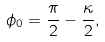Convert formula to latex. <formula><loc_0><loc_0><loc_500><loc_500>\phi _ { 0 } = \frac { \pi } { 2 } - \frac { \kappa } { 2 } ,</formula> 